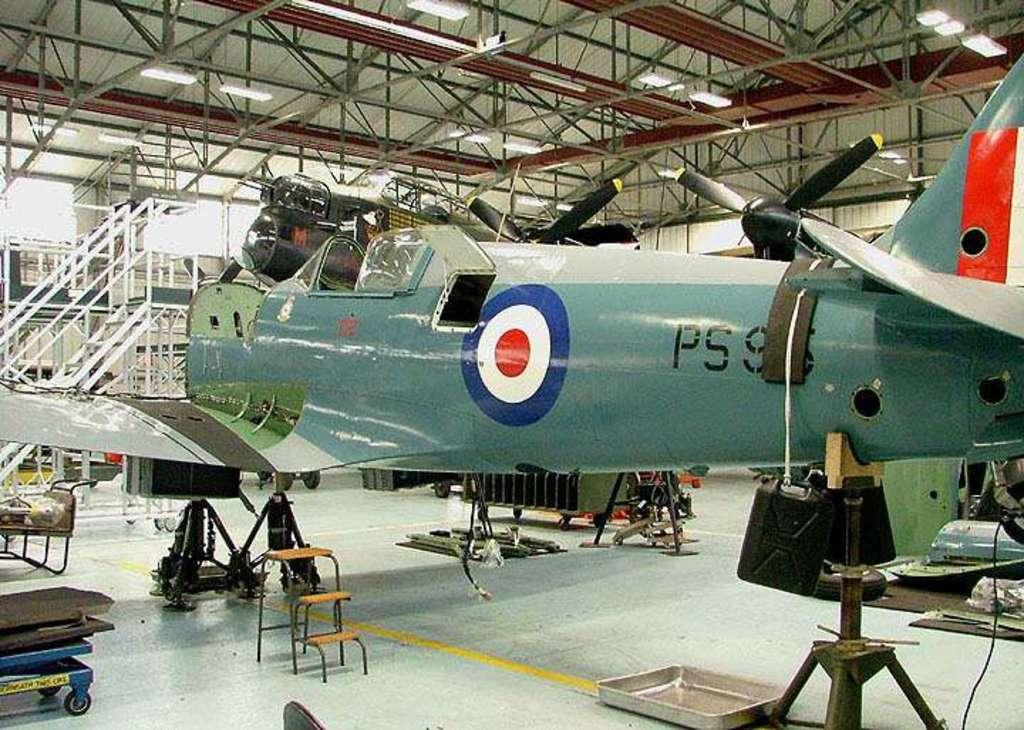Please provide a concise description of this image. In this image we can see an airplane on the stand. Behind the airline, we can see truss, lights and other objects. 